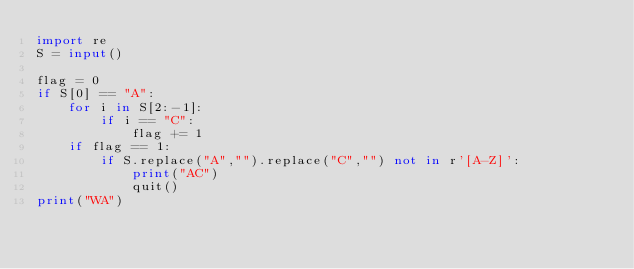Convert code to text. <code><loc_0><loc_0><loc_500><loc_500><_Python_>import re
S = input()

flag = 0
if S[0] == "A":
    for i in S[2:-1]:
        if i == "C":
            flag += 1
    if flag == 1:
        if S.replace("A","").replace("C","") not in r'[A-Z]':
            print("AC")
            quit()
print("WA")
</code> 